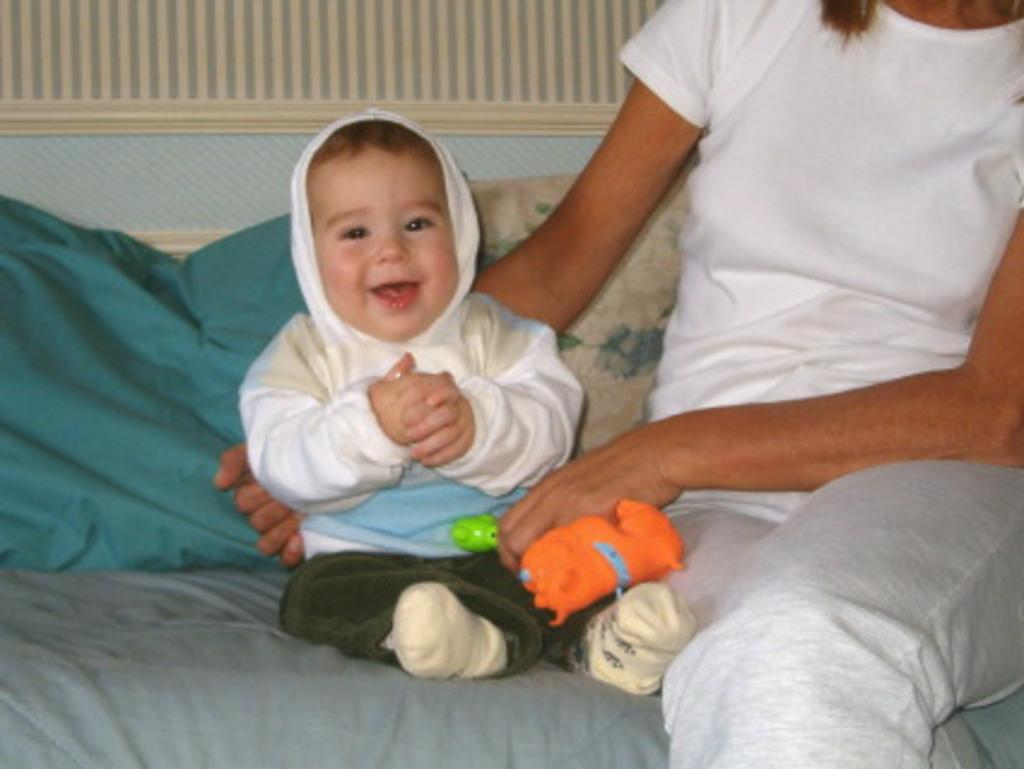What type of furniture is in the image? There is a sofa set in the image. What is on the sofa set? There is a baby and a person on the sofa set. What is the person doing on the sofa set? The person is holding toys. How many pillows are visible in the image? There are two pillows visible in the image. What type of nation is depicted on the dime in the image? There is no dime present in the image, so it is not possible to determine what type of nation might be depicted on it. 